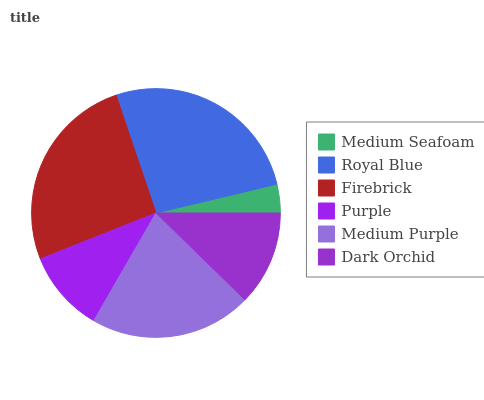Is Medium Seafoam the minimum?
Answer yes or no. Yes. Is Royal Blue the maximum?
Answer yes or no. Yes. Is Firebrick the minimum?
Answer yes or no. No. Is Firebrick the maximum?
Answer yes or no. No. Is Royal Blue greater than Firebrick?
Answer yes or no. Yes. Is Firebrick less than Royal Blue?
Answer yes or no. Yes. Is Firebrick greater than Royal Blue?
Answer yes or no. No. Is Royal Blue less than Firebrick?
Answer yes or no. No. Is Medium Purple the high median?
Answer yes or no. Yes. Is Dark Orchid the low median?
Answer yes or no. Yes. Is Firebrick the high median?
Answer yes or no. No. Is Purple the low median?
Answer yes or no. No. 